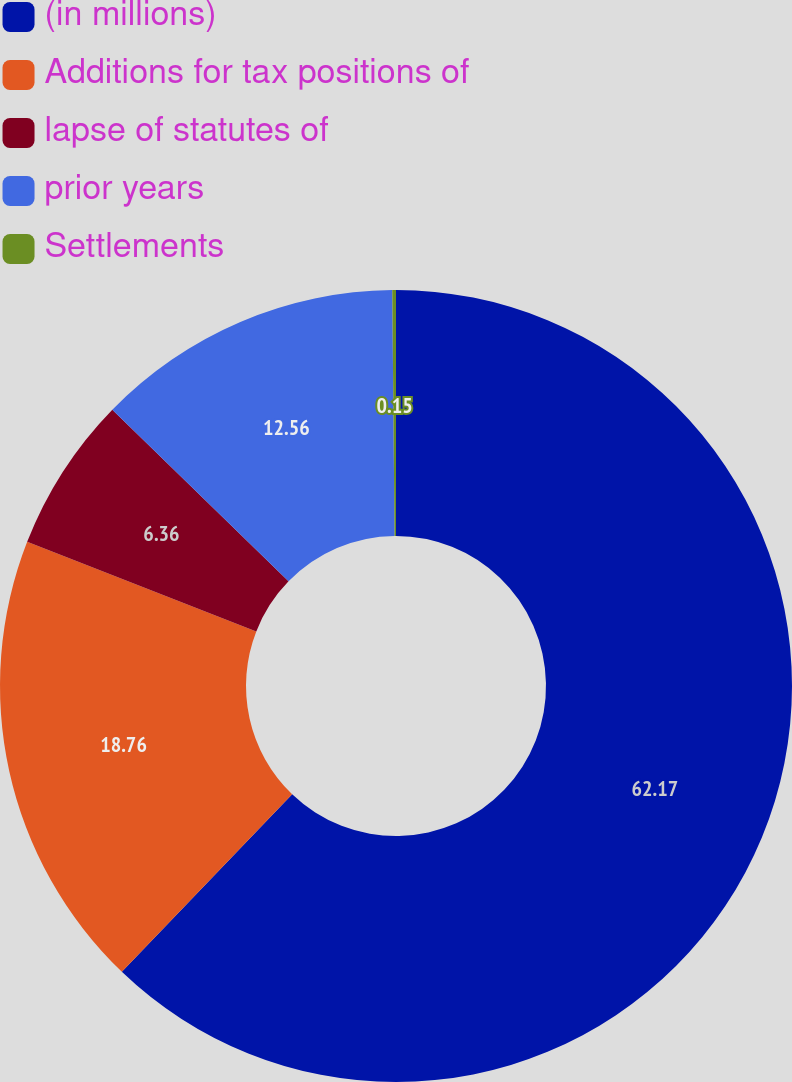<chart> <loc_0><loc_0><loc_500><loc_500><pie_chart><fcel>(in millions)<fcel>Additions for tax positions of<fcel>lapse of statutes of<fcel>prior years<fcel>Settlements<nl><fcel>62.17%<fcel>18.76%<fcel>6.36%<fcel>12.56%<fcel>0.15%<nl></chart> 